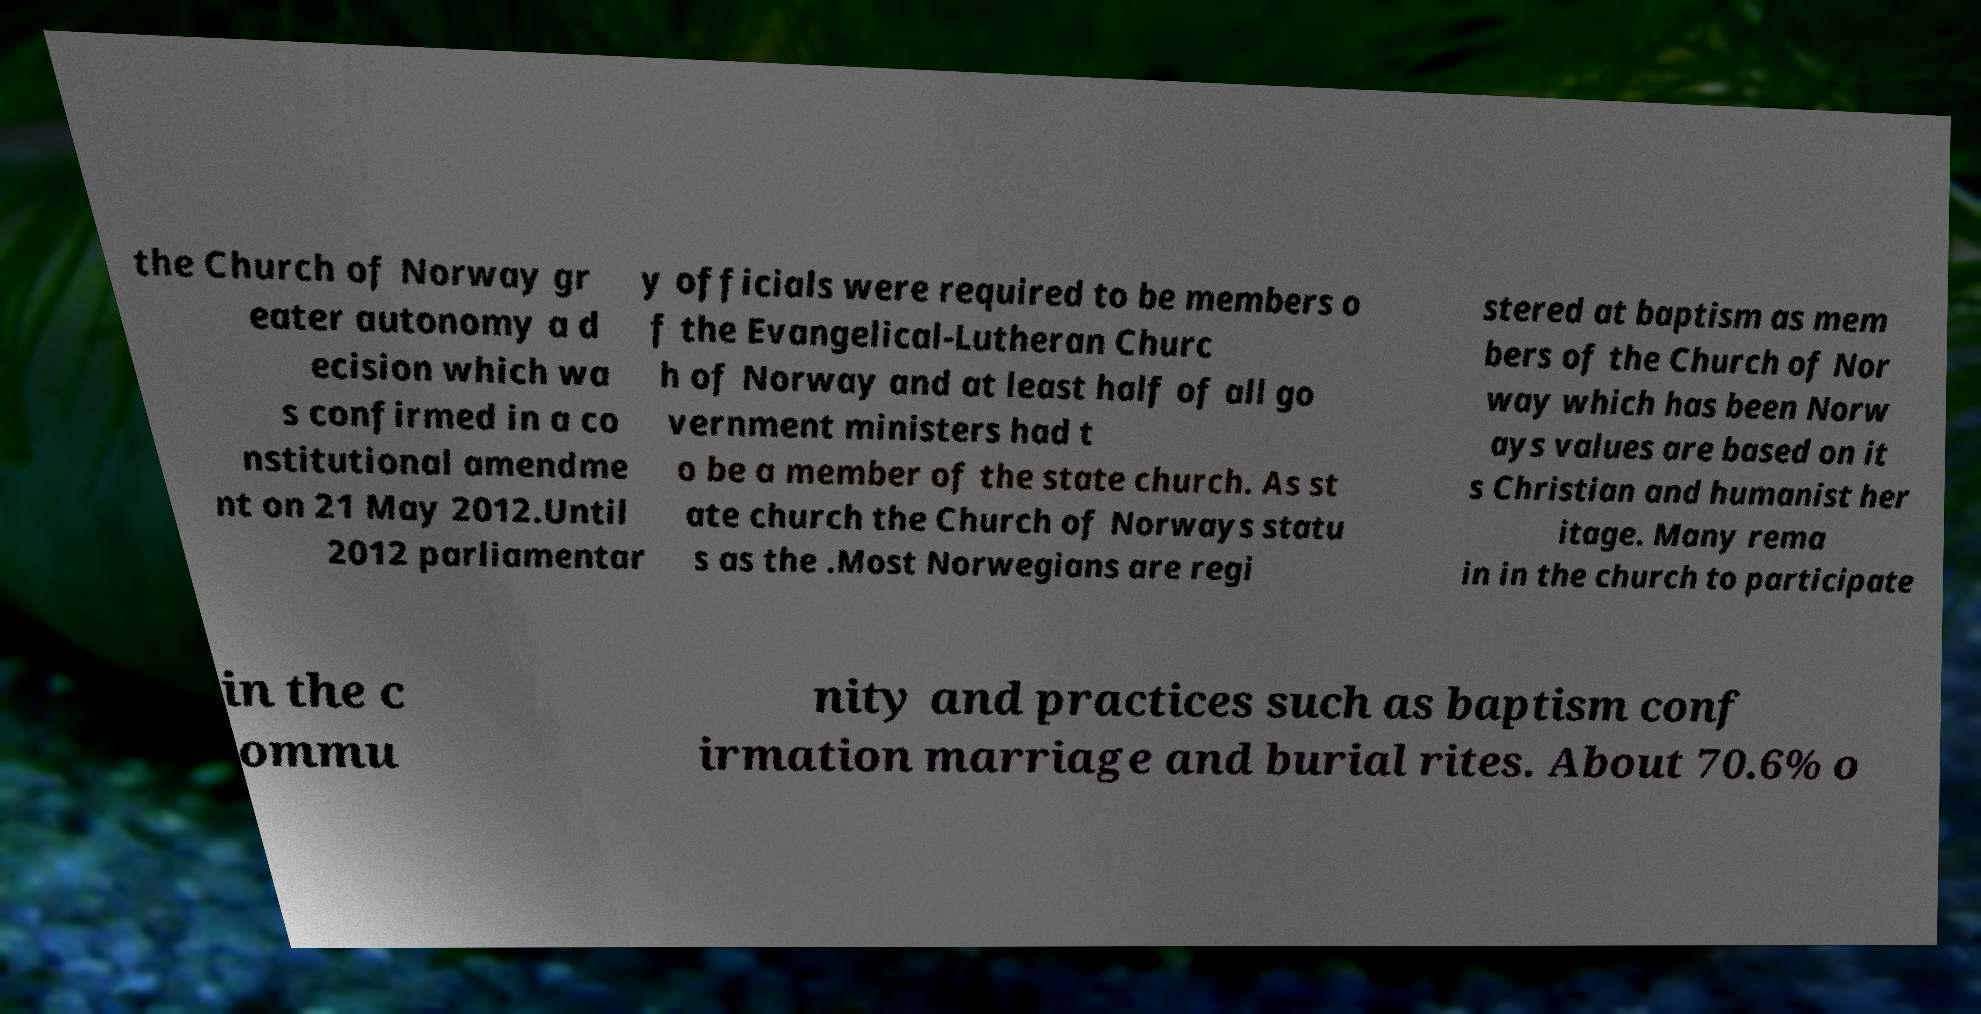Can you accurately transcribe the text from the provided image for me? the Church of Norway gr eater autonomy a d ecision which wa s confirmed in a co nstitutional amendme nt on 21 May 2012.Until 2012 parliamentar y officials were required to be members o f the Evangelical-Lutheran Churc h of Norway and at least half of all go vernment ministers had t o be a member of the state church. As st ate church the Church of Norways statu s as the .Most Norwegians are regi stered at baptism as mem bers of the Church of Nor way which has been Norw ays values are based on it s Christian and humanist her itage. Many rema in in the church to participate in the c ommu nity and practices such as baptism conf irmation marriage and burial rites. About 70.6% o 